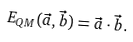Convert formula to latex. <formula><loc_0><loc_0><loc_500><loc_500>E _ { Q M } ( \vec { a } , \vec { b } ) = \vec { a } \cdot \vec { b } .</formula> 